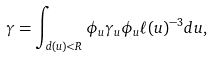<formula> <loc_0><loc_0><loc_500><loc_500>\gamma = \int _ { d ( u ) < R } \phi _ { u } \gamma _ { u } \phi _ { u } \ell ( u ) ^ { - 3 } d u ,</formula> 